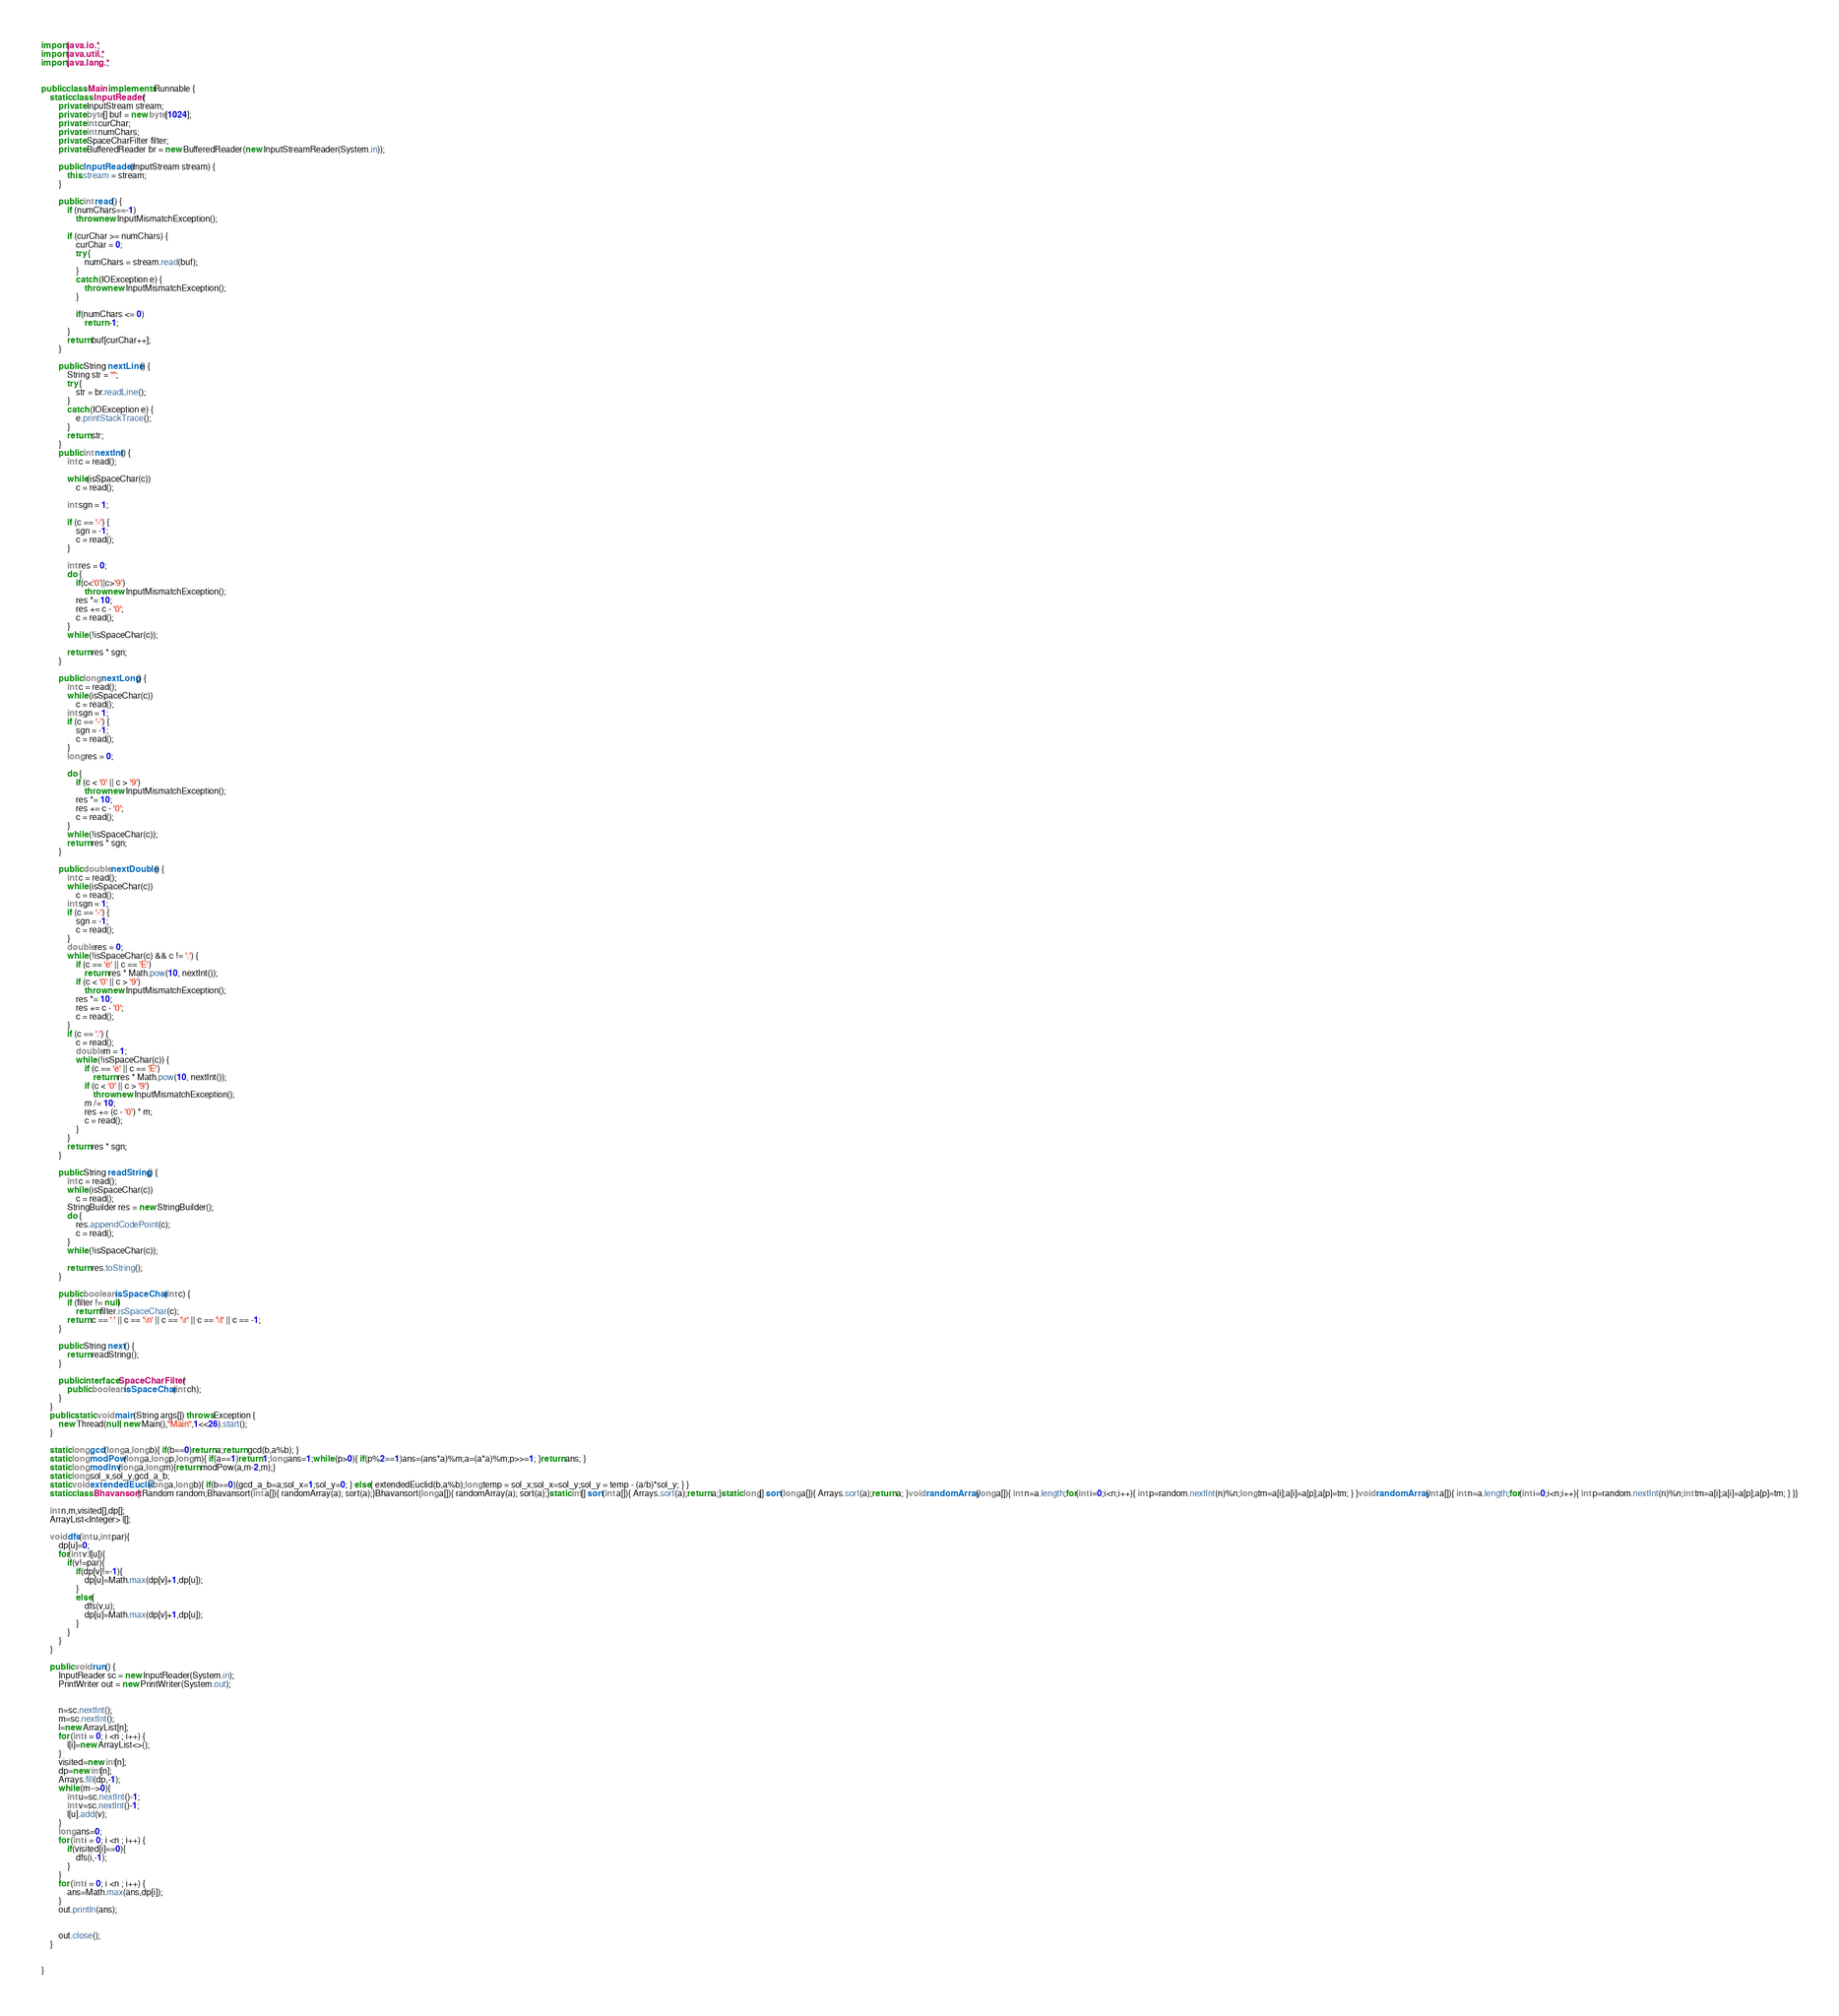Convert code to text. <code><loc_0><loc_0><loc_500><loc_500><_Java_>import java.io.*;
import java.util.*;
import java.lang.*;


public class Main implements Runnable {
    static class InputReader {
        private InputStream stream;
        private byte[] buf = new byte[1024];
        private int curChar;
        private int numChars;
        private SpaceCharFilter filter;
        private BufferedReader br = new BufferedReader(new InputStreamReader(System.in));

        public InputReader(InputStream stream) {
            this.stream = stream;
        }

        public int read() {
            if (numChars==-1)
                throw new InputMismatchException();

            if (curChar >= numChars) {
                curChar = 0;
                try {
                    numChars = stream.read(buf);
                }
                catch (IOException e) {
                    throw new InputMismatchException();
                }

                if(numChars <= 0)
                    return -1;
            }
            return buf[curChar++];
        }

        public String nextLine() {
            String str = "";
            try {
                str = br.readLine();
            }
            catch (IOException e) {
                e.printStackTrace();
            }
            return str;
        }
        public int nextInt() {
            int c = read();

            while(isSpaceChar(c))
                c = read();

            int sgn = 1;

            if (c == '-') {
                sgn = -1;
                c = read();
            }

            int res = 0;
            do {
                if(c<'0'||c>'9')
                    throw new InputMismatchException();
                res *= 10;
                res += c - '0';
                c = read();
            }
            while (!isSpaceChar(c));

            return res * sgn;
        }

        public long nextLong() {
            int c = read();
            while (isSpaceChar(c))
                c = read();
            int sgn = 1;
            if (c == '-') {
                sgn = -1;
                c = read();
            }
            long res = 0;

            do {
                if (c < '0' || c > '9')
                    throw new InputMismatchException();
                res *= 10;
                res += c - '0';
                c = read();
            }
            while (!isSpaceChar(c));
            return res * sgn;
        }

        public double nextDouble() {
            int c = read();
            while (isSpaceChar(c))
                c = read();
            int sgn = 1;
            if (c == '-') {
                sgn = -1;
                c = read();
            }
            double res = 0;
            while (!isSpaceChar(c) && c != '.') {
                if (c == 'e' || c == 'E')
                    return res * Math.pow(10, nextInt());
                if (c < '0' || c > '9')
                    throw new InputMismatchException();
                res *= 10;
                res += c - '0';
                c = read();
            }
            if (c == '.') {
                c = read();
                double m = 1;
                while (!isSpaceChar(c)) {
                    if (c == 'e' || c == 'E')
                        return res * Math.pow(10, nextInt());
                    if (c < '0' || c > '9')
                        throw new InputMismatchException();
                    m /= 10;
                    res += (c - '0') * m;
                    c = read();
                }
            }
            return res * sgn;
        }

        public String readString() {
            int c = read();
            while (isSpaceChar(c))
                c = read();
            StringBuilder res = new StringBuilder();
            do {
                res.appendCodePoint(c);
                c = read();
            }
            while (!isSpaceChar(c));

            return res.toString();
        }

        public boolean isSpaceChar(int c) {
            if (filter != null)
                return filter.isSpaceChar(c);
            return c == ' ' || c == '\n' || c == '\r' || c == '\t' || c == -1;
        }

        public String next() {
            return readString();
        }

        public interface SpaceCharFilter {
            public boolean isSpaceChar(int ch);
        }
    }
    public static void main(String args[]) throws Exception {
        new Thread(null, new Main(),"Main",1<<26).start();
    }

    static long gcd(long a,long b){ if(b==0)return a;return gcd(b,a%b); }
    static long modPow(long a,long p,long m){ if(a==1)return 1;long ans=1;while (p>0){ if(p%2==1)ans=(ans*a)%m;a=(a*a)%m;p>>=1; }return ans; }
    static long modInv(long a,long m){return modPow(a,m-2,m);}
    static long sol_x,sol_y,gcd_a_b;
    static void extendedEuclid(long a,long b){ if(b==0){gcd_a_b=a;sol_x=1;sol_y=0; } else{ extendedEuclid(b,a%b);long temp = sol_x;sol_x=sol_y;sol_y = temp - (a/b)*sol_y; } }
    static class Bhavansort{ Random random;Bhavansort(int a[]){ randomArray(a); sort(a);}Bhavansort(long a[]){ randomArray(a); sort(a);}static int[] sort(int a[]){ Arrays.sort(a);return a;}static long[] sort(long a[]){ Arrays.sort(a);return a; }void randomArray(long a[]){ int n=a.length;for(int i=0;i<n;i++){ int p=random.nextInt(n)%n;long tm=a[i];a[i]=a[p];a[p]=tm; } }void randomArray(int a[]){ int n=a.length;for(int i=0;i<n;i++){ int p=random.nextInt(n)%n;int tm=a[i];a[i]=a[p];a[p]=tm; } }}

    int n,m,visited[],dp[];
    ArrayList<Integer> l[];

    void dfs(int u,int par){
        dp[u]=0;
        for(int v:l[u]){
            if(v!=par){
                if(dp[v]!=-1){
                    dp[u]=Math.max(dp[v]+1,dp[u]);
                }
                else{
                    dfs(v,u);
                    dp[u]=Math.max(dp[v]+1,dp[u]);
                }
            }
        }
    }

    public void run() {
        InputReader sc = new InputReader(System.in);
        PrintWriter out = new PrintWriter(System.out);


        n=sc.nextInt();
        m=sc.nextInt();
        l=new ArrayList[n];
        for (int i = 0; i <n ; i++) {
            l[i]=new ArrayList<>();
        }
        visited=new int[n];
        dp=new int[n];
        Arrays.fill(dp,-1);
        while (m-->0){
            int u=sc.nextInt()-1;
            int v=sc.nextInt()-1;
            l[u].add(v);
        }
        long ans=0;
        for (int i = 0; i <n ; i++) {
            if(visited[i]==0){
                dfs(i,-1);
            }
        }
        for (int i = 0; i <n ; i++) {
            ans=Math.max(ans,dp[i]);
        }
        out.println(ans);


        out.close();
    }


}</code> 